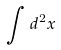<formula> <loc_0><loc_0><loc_500><loc_500>\int d ^ { 2 } x</formula> 